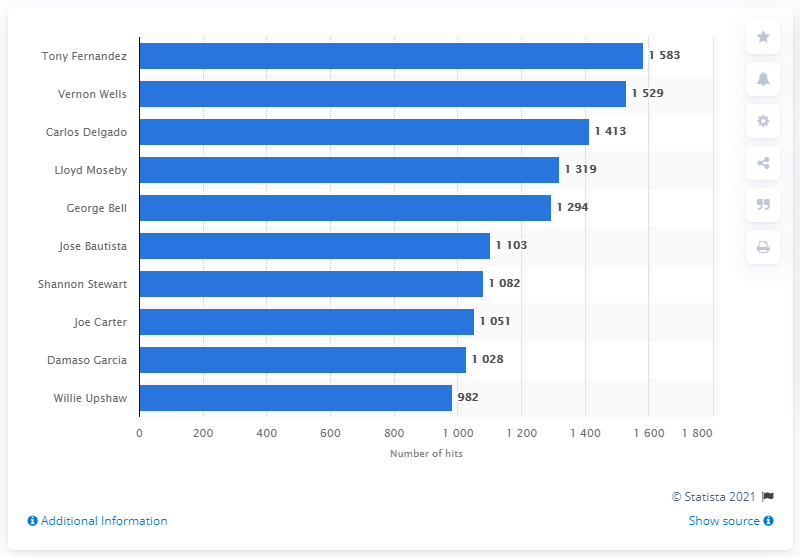Point out several critical features in this image. Of all the leaders listed in the chart, Willie Upshaw has the least amount of followers. Tony Fernandez has the most hits in the history of the Toronto Blue Jays franchise. The most popular leader has significantly more hits than the least popular one, with a difference of 601. 